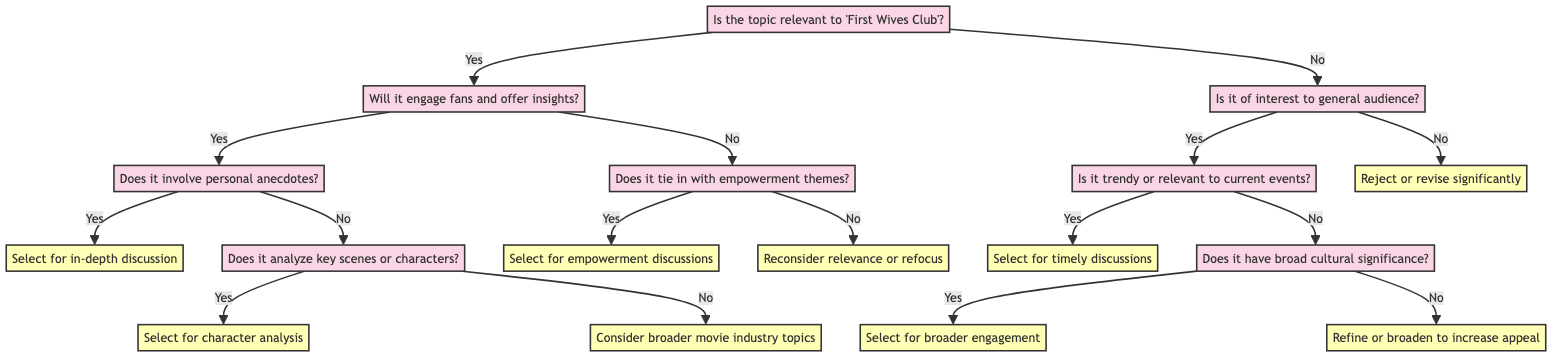Is the first question asking about the relevance to "First Wives Club"? The first node of the diagram asks if the topic is relevant to "First Wives Club". This sets the foundation for the decision tree, determining the initial pathway through the diagram.
Answer: Yes How many decisions are represented in this diagram? By counting the nodes that specify a decision, we find that there are eight decision nodes: Select for in-depth discussion, Select for character analysis, Consider broader movie industry topics, Select for empowerment discussions, Reconsider relevance or refocus, Select for timely discussions, Select for broader engagement, and Refine or broaden to increase appeal.
Answer: Eight What is the outcome if the topic does not engage fans? The flow will lead to checking if the topic ties in with women's empowerment and friendship themes. If it does not, the decision will be to reconsider relevance or refocus the topic.
Answer: Reconsider relevance or refocus What does the diagram indicate if the topic has broad cultural significance? If the topic is of interest to a general audience and has broad cultural significance, the decision is to select this topic for broader engagement, suggesting that it can attract a wider audience.
Answer: Select for broader engagement If the topic is not relevant and not of interest to a general audience, what should be done? The flow from the second 'no' leads to a decision noting that the topic should be rejected or revised significantly, indicating that it lacks value in the given context.
Answer: Reject or revise significantly What should be selected if the topic is trendy and relevant to current events? If the topic is established as of interest to a general audience and is also trendy or relevant to current events, the diagram suggests selecting this topic for timely discussions, emphasizing its relevance to the present time.
Answer: Select for timely discussions What follows after selecting a topic for character analysis? After deciding to select a topic for character analysis, the pathway implies that there is no further action from this decision node, which results in concluding the decision-making process for that branch.
Answer: End of pathway What is the first pathway if the topic relates to legacy and themes of "First Wives Club"? If the topic is relevant to the legacy and themes of "First Wives Club", the next question confirms if it will engage fans and offer insights, indicating that relevance initiates a specific sequence in the discussion process.
Answer: Engage fans and offer insights 